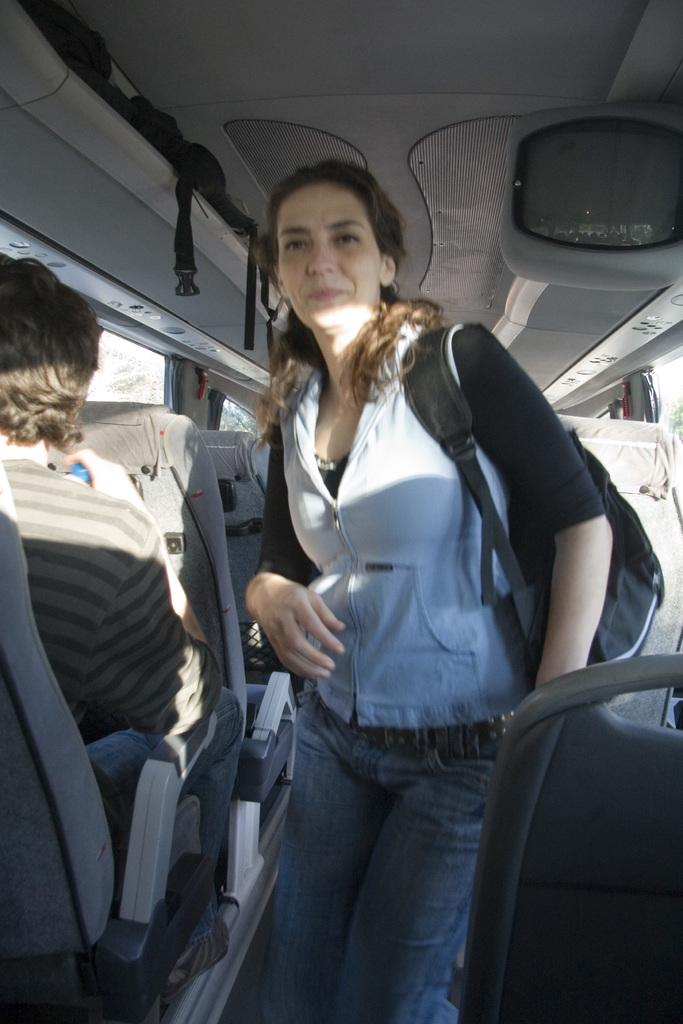What is the person in the vehicle doing? The person is sitting in the vehicle. Who else is in the vehicle, and what are they doing? There is a woman standing in the vehicle. What is the woman wearing that is visible in the image? The woman is wearing a bag. What type of entertainment device is present in the vehicle? There is a television in the vehicle. What type of cloth is draped over the bat in the vehicle? There is no bat or cloth present in the vehicle; the image only features a person sitting, a woman standing, and a television. 